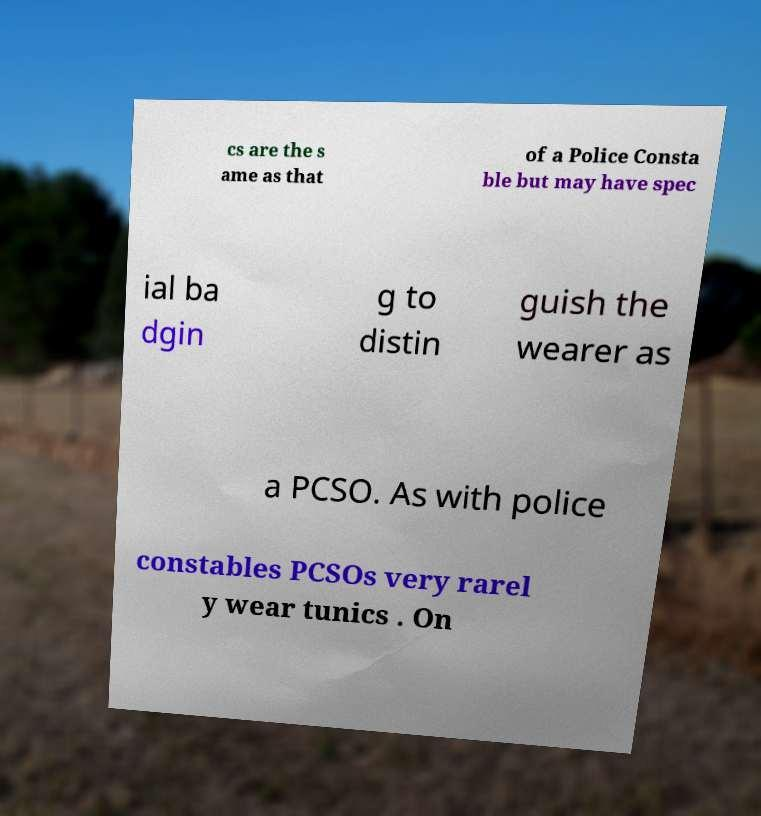What messages or text are displayed in this image? I need them in a readable, typed format. cs are the s ame as that of a Police Consta ble but may have spec ial ba dgin g to distin guish the wearer as a PCSO. As with police constables PCSOs very rarel y wear tunics . On 